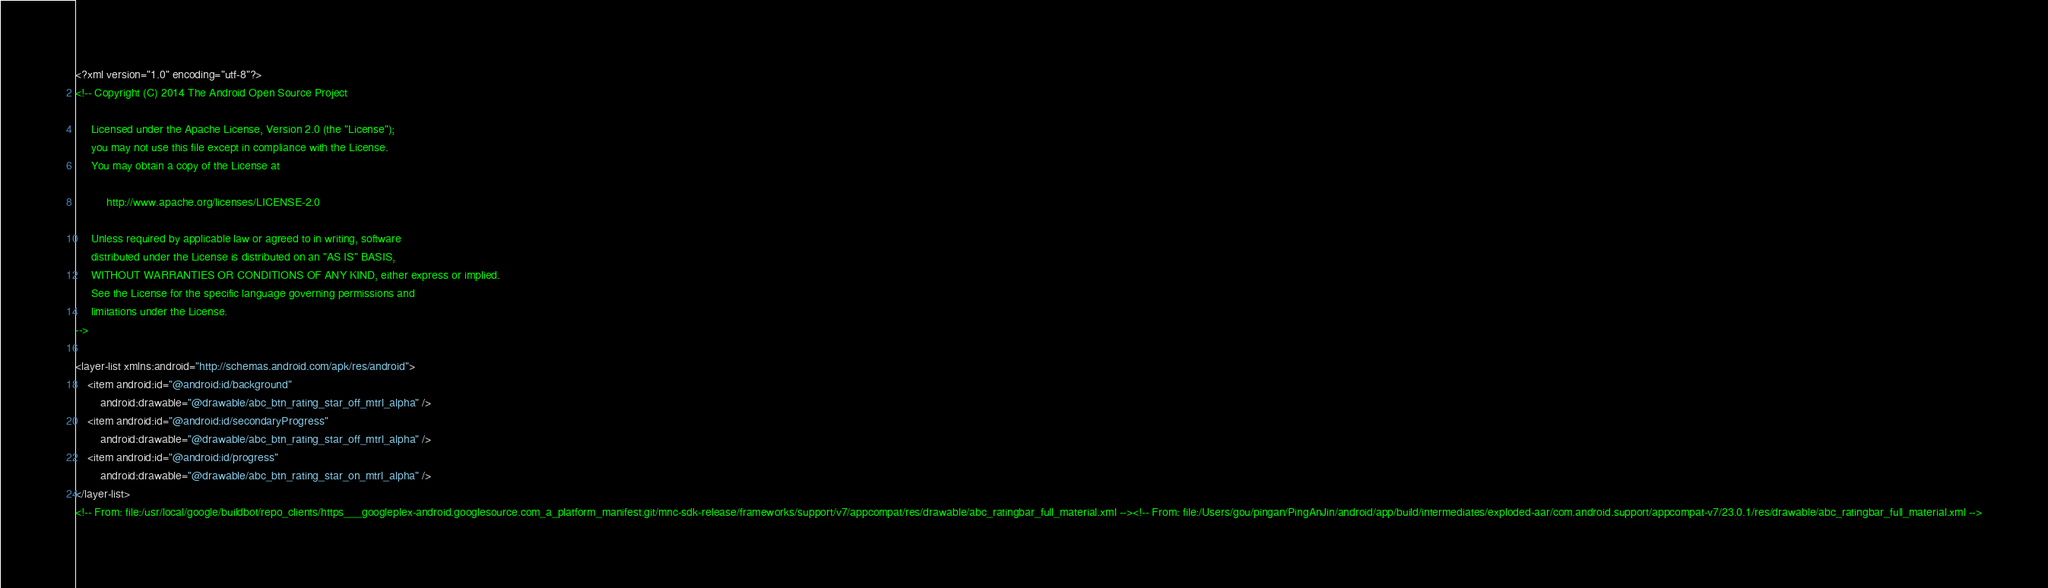<code> <loc_0><loc_0><loc_500><loc_500><_XML_><?xml version="1.0" encoding="utf-8"?>
<!-- Copyright (C) 2014 The Android Open Source Project

     Licensed under the Apache License, Version 2.0 (the "License");
     you may not use this file except in compliance with the License.
     You may obtain a copy of the License at

          http://www.apache.org/licenses/LICENSE-2.0

     Unless required by applicable law or agreed to in writing, software
     distributed under the License is distributed on an "AS IS" BASIS,
     WITHOUT WARRANTIES OR CONDITIONS OF ANY KIND, either express or implied.
     See the License for the specific language governing permissions and
     limitations under the License.
-->

<layer-list xmlns:android="http://schemas.android.com/apk/res/android">
    <item android:id="@android:id/background"
        android:drawable="@drawable/abc_btn_rating_star_off_mtrl_alpha" />
    <item android:id="@android:id/secondaryProgress"
        android:drawable="@drawable/abc_btn_rating_star_off_mtrl_alpha" />
    <item android:id="@android:id/progress"
        android:drawable="@drawable/abc_btn_rating_star_on_mtrl_alpha" />
</layer-list>
<!-- From: file:/usr/local/google/buildbot/repo_clients/https___googleplex-android.googlesource.com_a_platform_manifest.git/mnc-sdk-release/frameworks/support/v7/appcompat/res/drawable/abc_ratingbar_full_material.xml --><!-- From: file:/Users/gou/pingan/PingAnJin/android/app/build/intermediates/exploded-aar/com.android.support/appcompat-v7/23.0.1/res/drawable/abc_ratingbar_full_material.xml --></code> 